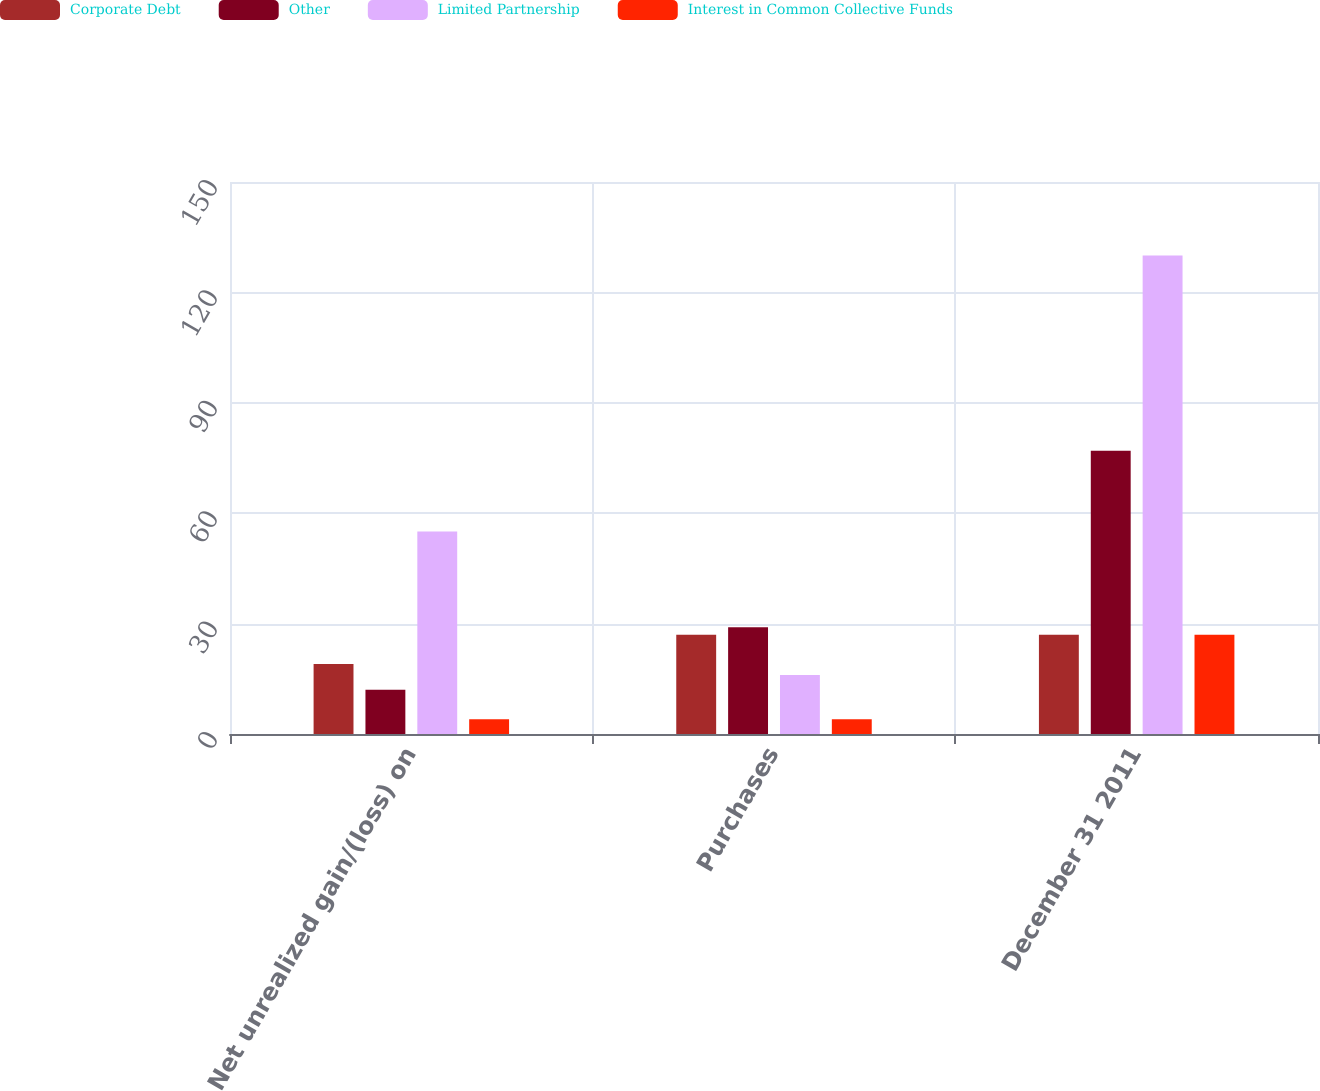<chart> <loc_0><loc_0><loc_500><loc_500><stacked_bar_chart><ecel><fcel>Net unrealized gain/(loss) on<fcel>Purchases<fcel>December 31 2011<nl><fcel>Corporate Debt<fcel>19<fcel>27<fcel>27<nl><fcel>Other<fcel>12<fcel>29<fcel>77<nl><fcel>Limited Partnership<fcel>55<fcel>16<fcel>130<nl><fcel>Interest in Common Collective Funds<fcel>4<fcel>4<fcel>27<nl></chart> 